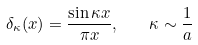<formula> <loc_0><loc_0><loc_500><loc_500>\delta _ { \kappa } ( x ) = \frac { \sin \kappa x } { \pi x } , \quad \kappa \sim \frac { 1 } { a }</formula> 